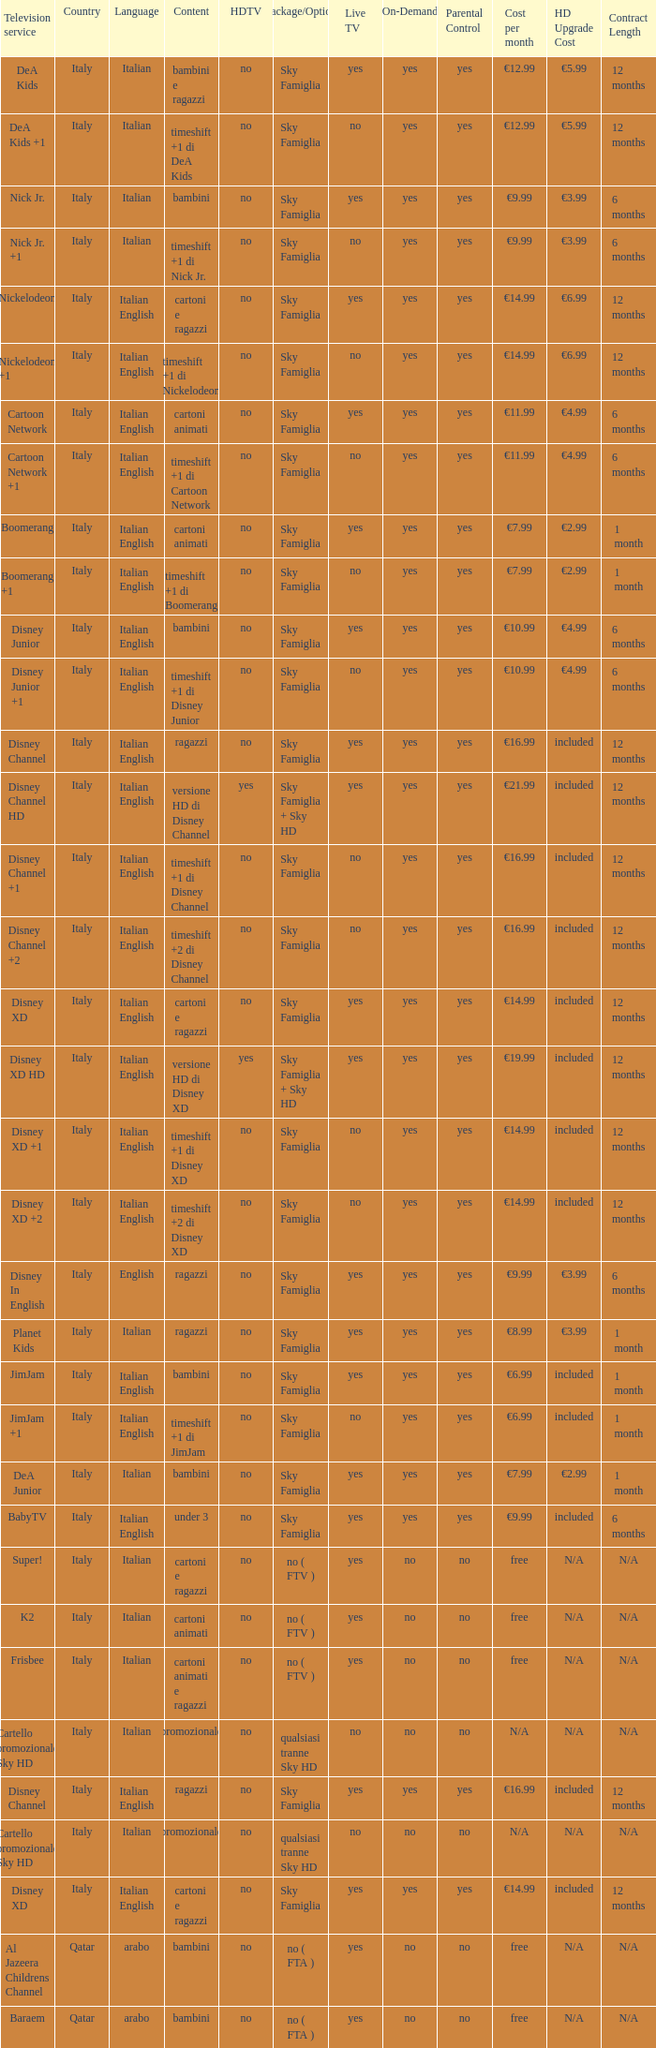What shows as Content for the Television service of nickelodeon +1? Timeshift +1 di nickelodeon. 